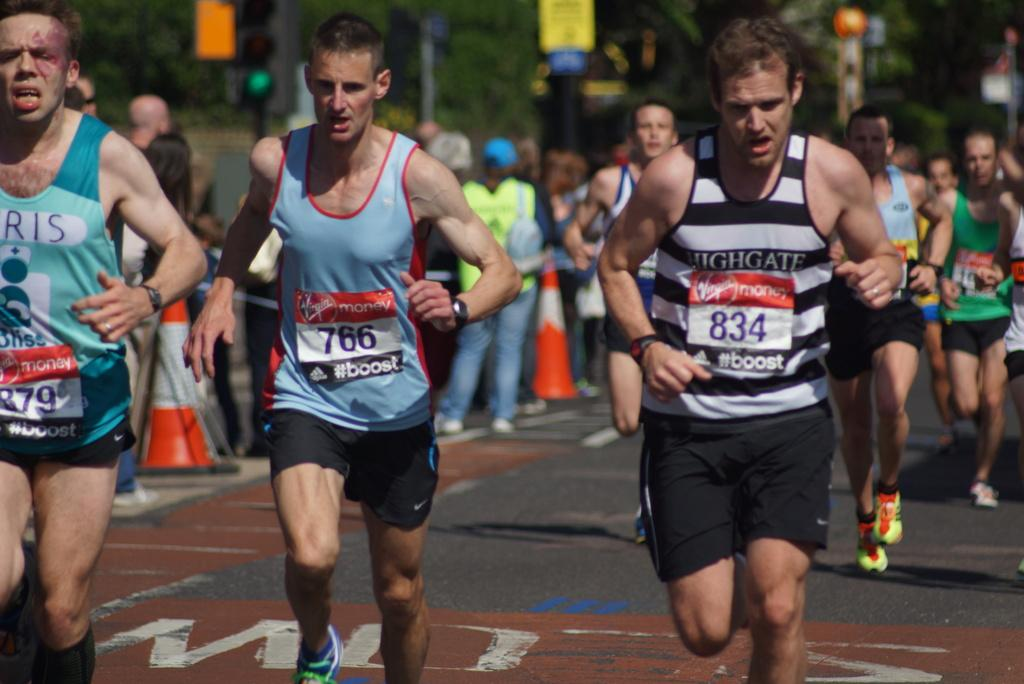What are the people in the image doing? The people in the image are running on the road. How would you describe the background of the image? The background is blurry. Can you identify any other people in the image? Yes, there are people in the background. What objects can be seen in the background? Traffic cones, a traffic signal, and trees are visible in the background. What type of hydrant is visible in the image? There is no hydrant present in the image. Can you tell me what type of law the lawyer in the image is practicing? There is no lawyer present in the image. 